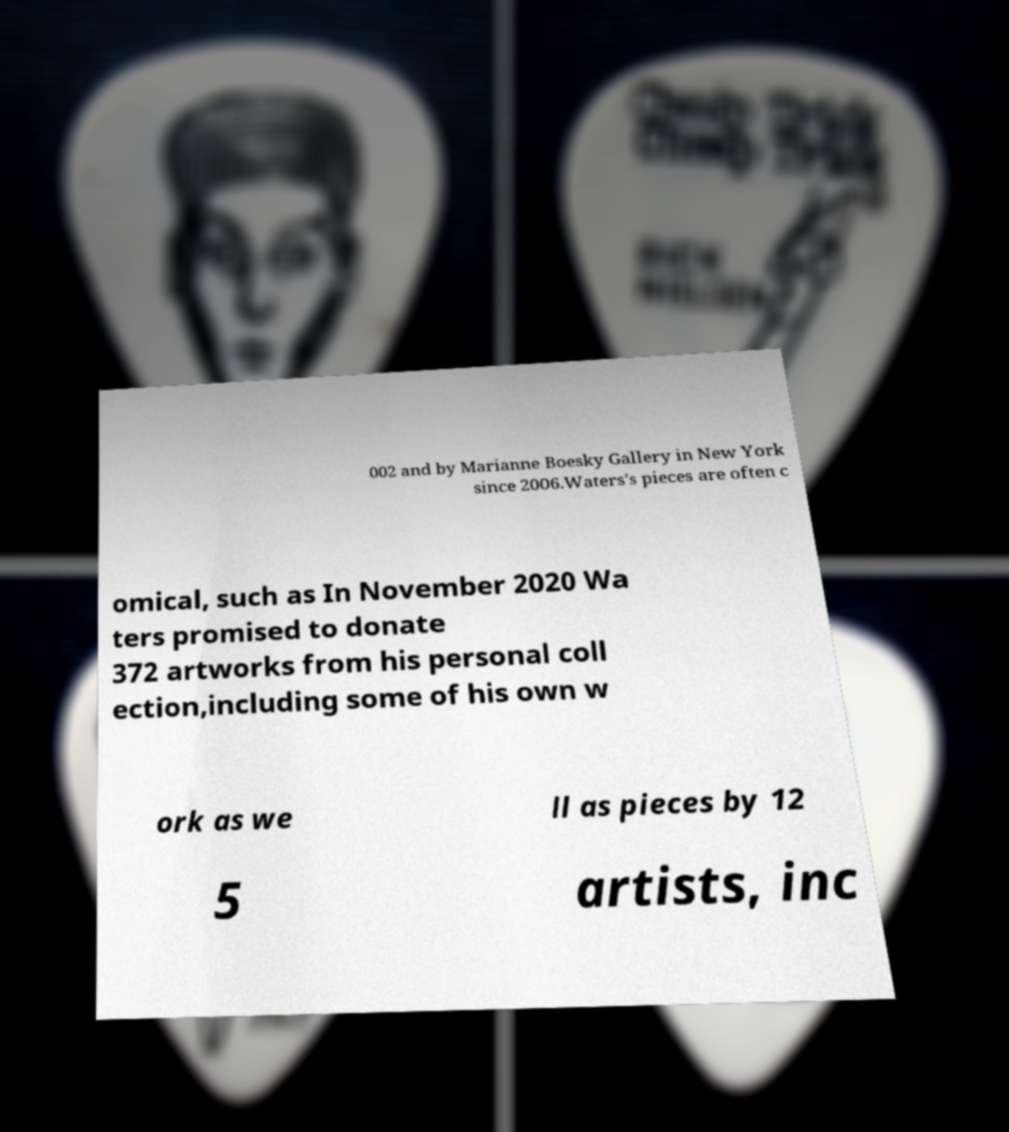Can you read and provide the text displayed in the image?This photo seems to have some interesting text. Can you extract and type it out for me? 002 and by Marianne Boesky Gallery in New York since 2006.Waters's pieces are often c omical, such as In November 2020 Wa ters promised to donate 372 artworks from his personal coll ection,including some of his own w ork as we ll as pieces by 12 5 artists, inc 